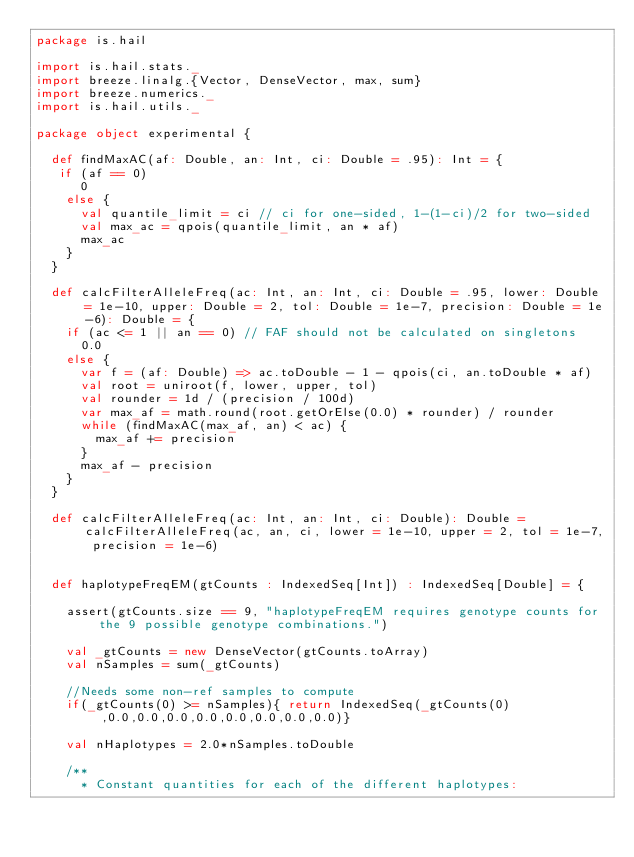<code> <loc_0><loc_0><loc_500><loc_500><_Scala_>package is.hail

import is.hail.stats._
import breeze.linalg.{Vector, DenseVector, max, sum}
import breeze.numerics._
import is.hail.utils._

package object experimental {

  def findMaxAC(af: Double, an: Int, ci: Double = .95): Int = {
   if (af == 0)
      0
    else {
      val quantile_limit = ci // ci for one-sided, 1-(1-ci)/2 for two-sided
      val max_ac = qpois(quantile_limit, an * af)
      max_ac
    }
  }

  def calcFilterAlleleFreq(ac: Int, an: Int, ci: Double = .95, lower: Double = 1e-10, upper: Double = 2, tol: Double = 1e-7, precision: Double = 1e-6): Double = {
    if (ac <= 1 || an == 0) // FAF should not be calculated on singletons
      0.0
    else {
      var f = (af: Double) => ac.toDouble - 1 - qpois(ci, an.toDouble * af)
      val root = uniroot(f, lower, upper, tol)
      val rounder = 1d / (precision / 100d)
      var max_af = math.round(root.getOrElse(0.0) * rounder) / rounder
      while (findMaxAC(max_af, an) < ac) {
        max_af += precision
      }
      max_af - precision
    }
  }

  def calcFilterAlleleFreq(ac: Int, an: Int, ci: Double): Double = calcFilterAlleleFreq(ac, an, ci, lower = 1e-10, upper = 2, tol = 1e-7, precision = 1e-6)


  def haplotypeFreqEM(gtCounts : IndexedSeq[Int]) : IndexedSeq[Double] = {

    assert(gtCounts.size == 9, "haplotypeFreqEM requires genotype counts for the 9 possible genotype combinations.")

    val _gtCounts = new DenseVector(gtCounts.toArray)
    val nSamples = sum(_gtCounts)

    //Needs some non-ref samples to compute
    if(_gtCounts(0) >= nSamples){ return IndexedSeq(_gtCounts(0),0.0,0.0,0.0,0.0,0.0,0.0,0.0,0.0)}

    val nHaplotypes = 2.0*nSamples.toDouble

    /**
      * Constant quantities for each of the different haplotypes:</code> 